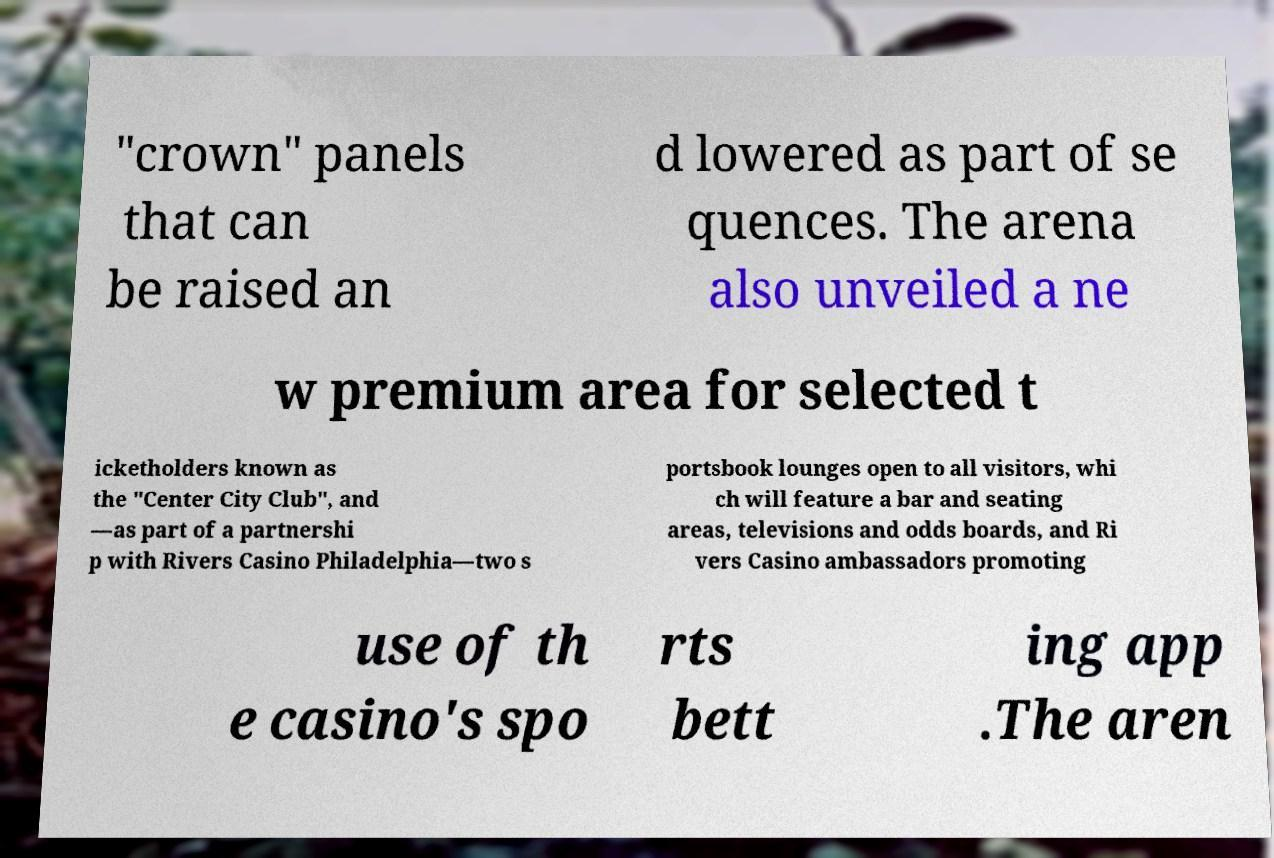There's text embedded in this image that I need extracted. Can you transcribe it verbatim? "crown" panels that can be raised an d lowered as part of se quences. The arena also unveiled a ne w premium area for selected t icketholders known as the "Center City Club", and —as part of a partnershi p with Rivers Casino Philadelphia—two s portsbook lounges open to all visitors, whi ch will feature a bar and seating areas, televisions and odds boards, and Ri vers Casino ambassadors promoting use of th e casino's spo rts bett ing app .The aren 